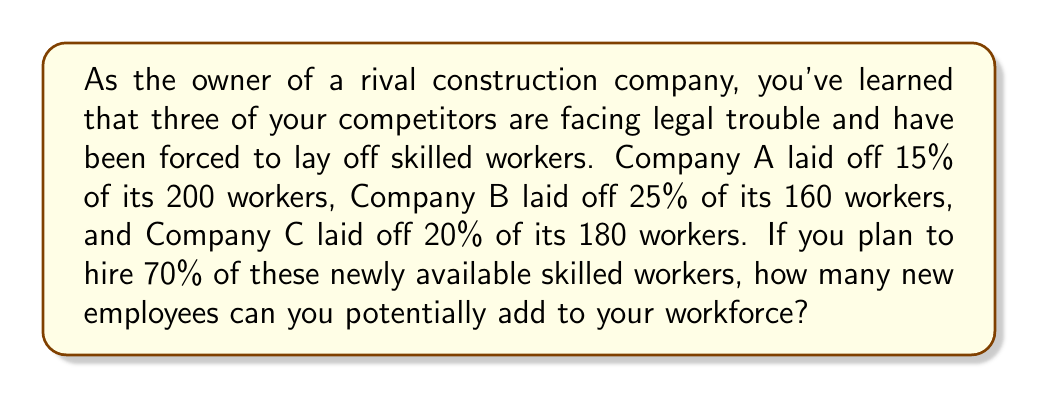Give your solution to this math problem. Let's break this down step-by-step:

1. Calculate the number of laid-off workers from each company:

   Company A: $200 \times 15\% = 200 \times 0.15 = 30$ workers
   Company B: $160 \times 25\% = 160 \times 0.25 = 40$ workers
   Company C: $180 \times 20\% = 180 \times 0.20 = 36$ workers

2. Sum up the total number of laid-off workers:

   $\text{Total laid-off} = 30 + 40 + 36 = 106$ workers

3. Calculate 70% of the total laid-off workers:

   $\text{Potential new hires} = 106 \times 70\% = 106 \times 0.70 = 74.2$

4. Since we can't hire a fractional number of workers, we round down to the nearest whole number:

   $\text{Potential new hires} = 74$ workers
Answer: 74 workers 